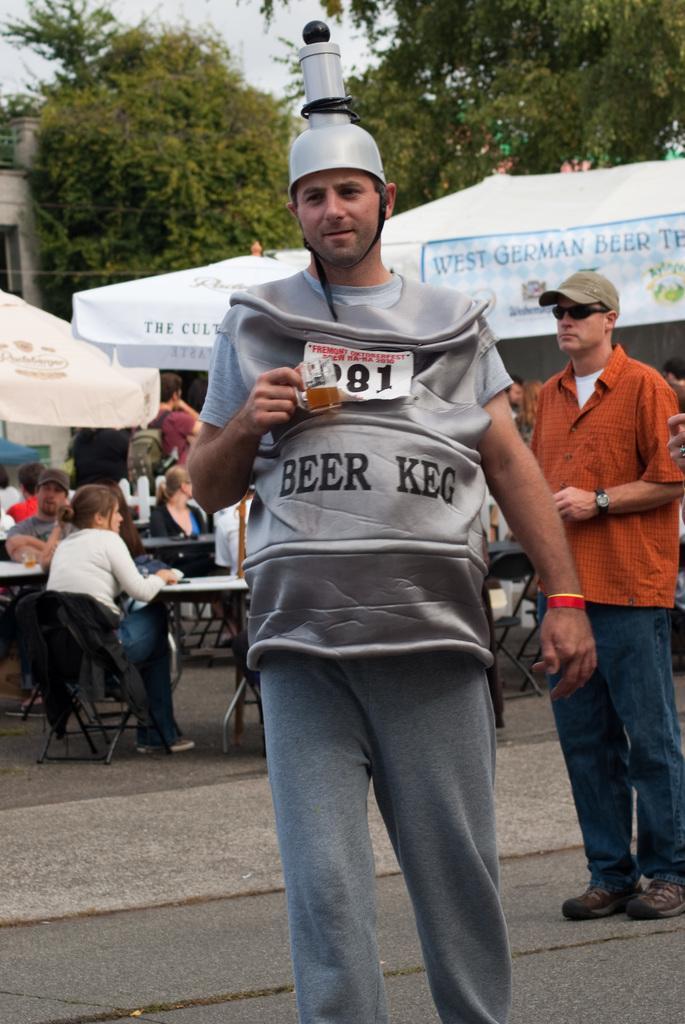In one or two sentences, can you explain what this image depicts? In this picture I can see few people are standing and I can see a man is holding a cup in his hand and few people are sitting in the chairs and I can see tents with some text on them and I can see a building, few trees in the back and a cloudy sky. 